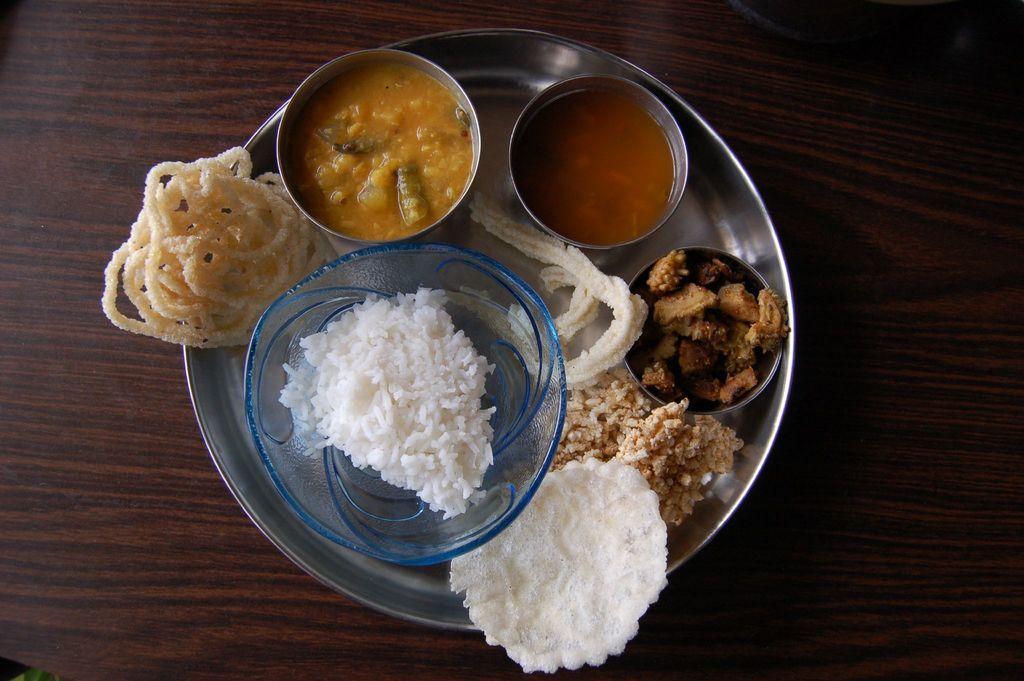Describe this image in one or two sentences. In this picture we can see plate, bowls and food on the wooden platform. 